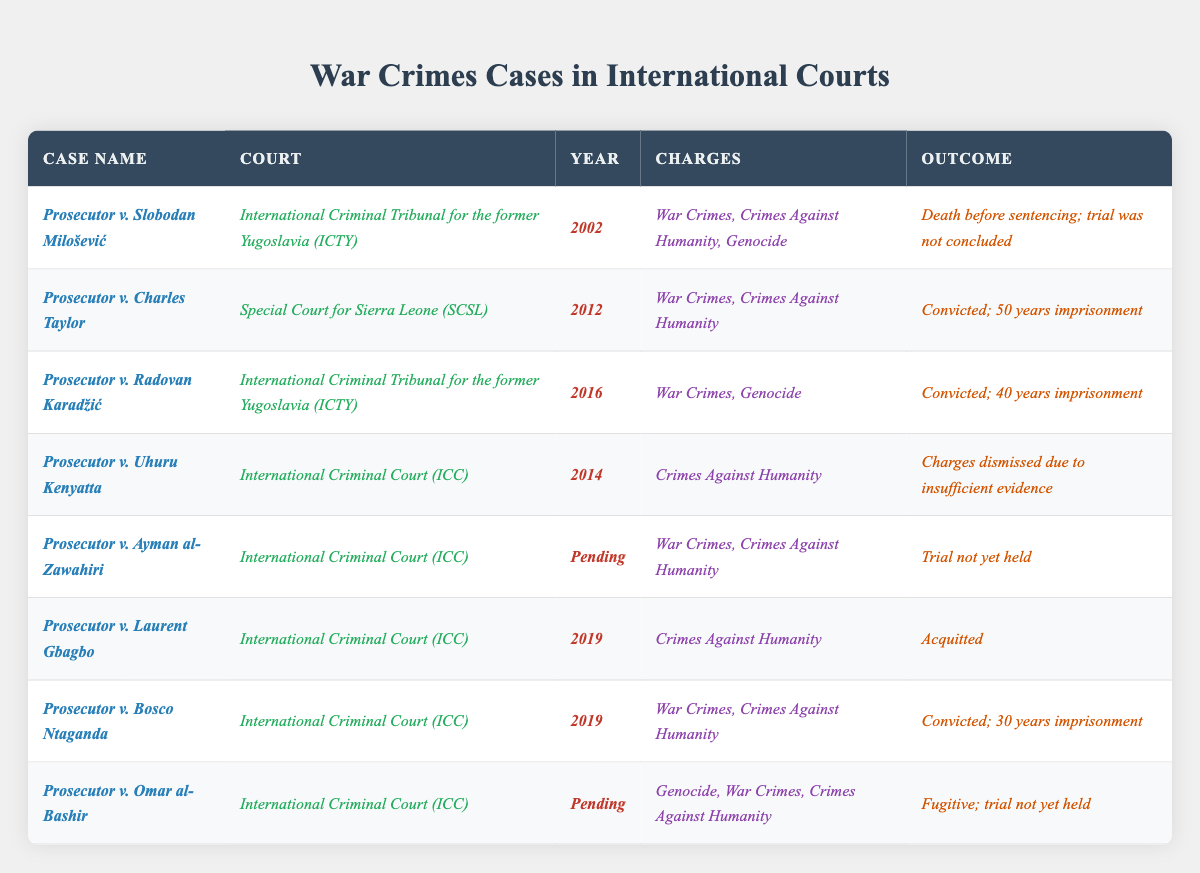What was the outcome of the case against Slobodan Milošević? The table states that Slobodan Milošević faced charges and died before sentencing, meaning the trial was not concluded.
Answer: Death before sentencing; trial not concluded How many cases resulted in convictions? By reviewing the table, there are three cases with convictions: Charles Taylor, Radovan Karadžić, and Bosco Ntaganda.
Answer: Three cases What charges were brought against Laurent Gbagbo? Looking at the table, the charges listed for Laurent Gbagbo are Crimes Against Humanity.
Answer: Crimes Against Humanity Did any of the cases involve the charge of Genocide? The table shows that both the cases against Slobodan Milošević and Radovan Karadžić included the charge of Genocide.
Answer: Yes Which court handled the case of Prosecutor v. Charles Taylor? The table indicates that the case against Charles Taylor was handled by the Special Court for Sierra Leone (SCSL).
Answer: Special Court for Sierra Leone (SCSL) What year was the case against Ayman al-Zawahiri brought? According to the table, the case against Ayman al-Zawahiri is listed as pending, meaning it has not yet been brought to court.
Answer: Pending How many years of imprisonment was Charles Taylor sentenced to? The table clearly mentions that Charles Taylor was convicted and sentenced to 50 years imprisonment.
Answer: 50 years imprisonment Are there any pending cases listed in the table? A quick glance at the table reveals two pending cases: against Ayman al-Zawahiri and Omar al-Bashir.
Answer: Yes, two pending cases What is the difference in sentencing years between Charles Taylor and Bosco Ntaganda? The table shows that Charles Taylor was sentenced to 50 years, while Bosco Ntaganda received 30 years; the difference is 20 years.
Answer: 20 years Which case had charges dismissed due to insufficient evidence? The table notes that the charges against Uhuru Kenyatta were dismissed due to insufficient evidence.
Answer: Prosecutor v. Uhuru Kenyatta What is the most recent case listed in the table? By examining the years in the table, the most recent case is Prosecutor v. Laurent Gbagbo from 2019.
Answer: Prosecutor v. Laurent Gbagbo In how many recent years (2010 onwards) did the ICC deliver verdicts? The table shows verdicts delivered by the ICC in 2014 and 2019, which totals two years with deliverances in the range.
Answer: Two years Which case has not yet held a trial and involves charges of War Crimes? The table lists Prosecutor v. Ayman al-Zawahiri as having not yet held a trial with charges including War Crimes.
Answer: Prosecutor v. Ayman al-Zawahiri 